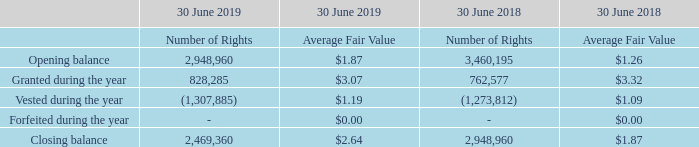21 Share-based payments
(a) Performance rights
The performance rights plan was established by the Board of Directors to provide long-term incentives to the Group’s Senior Executives based on total shareholder returns (TSR) taking into account the Group’s financial and operational performance. Under the Plan, eligible participants may be granted performance rights on terms and conditions determined by the Board from time to time. Performance rights were granted during the course of FY17, FY18 and FY19. The vesting conditions for grants relate to TSR exceeding the ASX 200 Accumulation Index over the measurement period. Vesting of the rights will be tested on or around the day following the release of each of the annual results for the years ended 30 June 2019, 2020 and 2021 respectively.
Performance rights are granted by the Company for nil consideration. The Board has discretion to determine if the value will be provided in shares, cash or a combination of shares and cash. Rights granted under the plan carry no dividend or voting rights.
The fair value of the rights at the date of valuation was determined using the Black-Scholes Option Pricing Model to be equal to the volume weighted-average price (VWAP) ending on the day before the grant date, less the dividends expected over the period from the expected grant date to the completion of the measurement period, adjusted for the expected probability of achieving the vesting conditions.
How was the fair value of the rights at the date of valuation determined? Using the black-scholes option pricing model to be equal to the volume weighted-average price (vwap) ending on the day before the grant date, less the dividends expected over the period from the expected grant date to the completion of the measurement period, adjusted for the expected probability of achieving the vesting conditions. When will the vesting of the rights be tested on? On or around the day following the release of each of the annual results for the years ended 30 june 2019, 2020 and 2021 respectively. How much performance rights was granted in FY18? 762,577. What was the average difference between number of rights in opening and closing balance for both years? ((2,948,960 - 2,469,360) + (3,460,195 - 2,948,960)) / 2 
Answer: 495417.5. Which year had more rights vested? 2019: (1,307,885) vs 2018: (1,273,812)
Answer: 2019. What was the percentage change in average fair value at closing balance between 2018 and 2019?
Answer scale should be: percent. (2.64 - 1.87) / 1.87 
Answer: 41.18. 